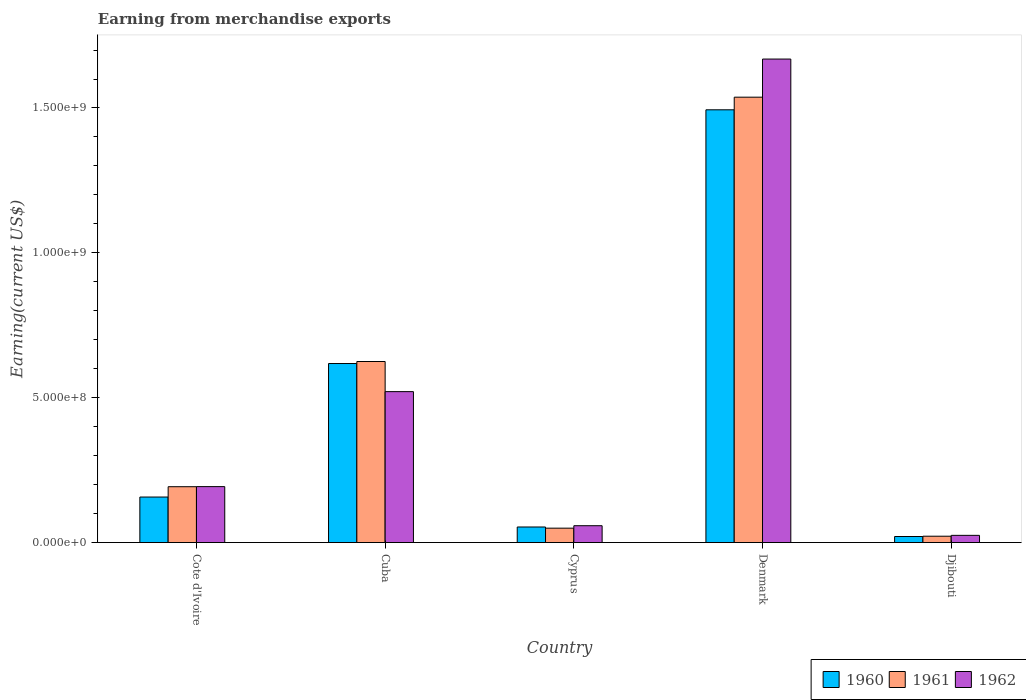How many groups of bars are there?
Provide a short and direct response. 5. Are the number of bars per tick equal to the number of legend labels?
Your answer should be compact. Yes. Are the number of bars on each tick of the X-axis equal?
Make the answer very short. Yes. What is the label of the 4th group of bars from the left?
Provide a short and direct response. Denmark. In how many cases, is the number of bars for a given country not equal to the number of legend labels?
Provide a succinct answer. 0. What is the amount earned from merchandise exports in 1962 in Denmark?
Give a very brief answer. 1.67e+09. Across all countries, what is the maximum amount earned from merchandise exports in 1960?
Provide a succinct answer. 1.49e+09. Across all countries, what is the minimum amount earned from merchandise exports in 1961?
Provide a short and direct response. 2.20e+07. In which country was the amount earned from merchandise exports in 1962 maximum?
Provide a succinct answer. Denmark. In which country was the amount earned from merchandise exports in 1961 minimum?
Offer a terse response. Djibouti. What is the total amount earned from merchandise exports in 1962 in the graph?
Provide a short and direct response. 2.47e+09. What is the difference between the amount earned from merchandise exports in 1961 in Cuba and that in Cyprus?
Ensure brevity in your answer.  5.75e+08. What is the difference between the amount earned from merchandise exports in 1962 in Denmark and the amount earned from merchandise exports in 1960 in Cyprus?
Make the answer very short. 1.62e+09. What is the average amount earned from merchandise exports in 1960 per country?
Ensure brevity in your answer.  4.69e+08. What is the difference between the amount earned from merchandise exports of/in 1960 and amount earned from merchandise exports of/in 1962 in Denmark?
Make the answer very short. -1.75e+08. What is the ratio of the amount earned from merchandise exports in 1960 in Cote d'Ivoire to that in Cyprus?
Offer a very short reply. 2.92. Is the amount earned from merchandise exports in 1961 in Cote d'Ivoire less than that in Djibouti?
Your answer should be very brief. No. Is the difference between the amount earned from merchandise exports in 1960 in Cote d'Ivoire and Cyprus greater than the difference between the amount earned from merchandise exports in 1962 in Cote d'Ivoire and Cyprus?
Offer a very short reply. No. What is the difference between the highest and the second highest amount earned from merchandise exports in 1960?
Your answer should be compact. 8.76e+08. What is the difference between the highest and the lowest amount earned from merchandise exports in 1960?
Make the answer very short. 1.47e+09. In how many countries, is the amount earned from merchandise exports in 1960 greater than the average amount earned from merchandise exports in 1960 taken over all countries?
Your answer should be compact. 2. Is the sum of the amount earned from merchandise exports in 1962 in Cote d'Ivoire and Cyprus greater than the maximum amount earned from merchandise exports in 1960 across all countries?
Your answer should be compact. No. What does the 3rd bar from the left in Denmark represents?
Offer a very short reply. 1962. Is it the case that in every country, the sum of the amount earned from merchandise exports in 1961 and amount earned from merchandise exports in 1960 is greater than the amount earned from merchandise exports in 1962?
Provide a succinct answer. Yes. How many bars are there?
Offer a very short reply. 15. Are the values on the major ticks of Y-axis written in scientific E-notation?
Ensure brevity in your answer.  Yes. How many legend labels are there?
Keep it short and to the point. 3. How are the legend labels stacked?
Keep it short and to the point. Horizontal. What is the title of the graph?
Provide a succinct answer. Earning from merchandise exports. What is the label or title of the X-axis?
Offer a terse response. Country. What is the label or title of the Y-axis?
Provide a short and direct response. Earning(current US$). What is the Earning(current US$) of 1960 in Cote d'Ivoire?
Provide a short and direct response. 1.57e+08. What is the Earning(current US$) in 1961 in Cote d'Ivoire?
Provide a short and direct response. 1.93e+08. What is the Earning(current US$) of 1962 in Cote d'Ivoire?
Provide a succinct answer. 1.93e+08. What is the Earning(current US$) of 1960 in Cuba?
Give a very brief answer. 6.18e+08. What is the Earning(current US$) of 1961 in Cuba?
Your answer should be very brief. 6.25e+08. What is the Earning(current US$) in 1962 in Cuba?
Keep it short and to the point. 5.21e+08. What is the Earning(current US$) in 1960 in Cyprus?
Make the answer very short. 5.38e+07. What is the Earning(current US$) of 1961 in Cyprus?
Give a very brief answer. 4.98e+07. What is the Earning(current US$) of 1962 in Cyprus?
Your response must be concise. 5.82e+07. What is the Earning(current US$) in 1960 in Denmark?
Ensure brevity in your answer.  1.49e+09. What is the Earning(current US$) of 1961 in Denmark?
Offer a very short reply. 1.54e+09. What is the Earning(current US$) of 1962 in Denmark?
Your answer should be very brief. 1.67e+09. What is the Earning(current US$) in 1960 in Djibouti?
Make the answer very short. 2.10e+07. What is the Earning(current US$) in 1961 in Djibouti?
Your response must be concise. 2.20e+07. What is the Earning(current US$) of 1962 in Djibouti?
Keep it short and to the point. 2.50e+07. Across all countries, what is the maximum Earning(current US$) in 1960?
Provide a succinct answer. 1.49e+09. Across all countries, what is the maximum Earning(current US$) of 1961?
Ensure brevity in your answer.  1.54e+09. Across all countries, what is the maximum Earning(current US$) of 1962?
Keep it short and to the point. 1.67e+09. Across all countries, what is the minimum Earning(current US$) in 1960?
Give a very brief answer. 2.10e+07. Across all countries, what is the minimum Earning(current US$) of 1961?
Your answer should be compact. 2.20e+07. Across all countries, what is the minimum Earning(current US$) in 1962?
Your response must be concise. 2.50e+07. What is the total Earning(current US$) of 1960 in the graph?
Give a very brief answer. 2.34e+09. What is the total Earning(current US$) of 1961 in the graph?
Keep it short and to the point. 2.43e+09. What is the total Earning(current US$) in 1962 in the graph?
Make the answer very short. 2.47e+09. What is the difference between the Earning(current US$) of 1960 in Cote d'Ivoire and that in Cuba?
Your answer should be compact. -4.61e+08. What is the difference between the Earning(current US$) of 1961 in Cote d'Ivoire and that in Cuba?
Your answer should be compact. -4.32e+08. What is the difference between the Earning(current US$) in 1962 in Cote d'Ivoire and that in Cuba?
Offer a terse response. -3.28e+08. What is the difference between the Earning(current US$) in 1960 in Cote d'Ivoire and that in Cyprus?
Your answer should be compact. 1.03e+08. What is the difference between the Earning(current US$) in 1961 in Cote d'Ivoire and that in Cyprus?
Your answer should be compact. 1.43e+08. What is the difference between the Earning(current US$) in 1962 in Cote d'Ivoire and that in Cyprus?
Keep it short and to the point. 1.35e+08. What is the difference between the Earning(current US$) in 1960 in Cote d'Ivoire and that in Denmark?
Make the answer very short. -1.34e+09. What is the difference between the Earning(current US$) in 1961 in Cote d'Ivoire and that in Denmark?
Ensure brevity in your answer.  -1.34e+09. What is the difference between the Earning(current US$) in 1962 in Cote d'Ivoire and that in Denmark?
Make the answer very short. -1.48e+09. What is the difference between the Earning(current US$) in 1960 in Cote d'Ivoire and that in Djibouti?
Ensure brevity in your answer.  1.36e+08. What is the difference between the Earning(current US$) of 1961 in Cote d'Ivoire and that in Djibouti?
Offer a very short reply. 1.71e+08. What is the difference between the Earning(current US$) in 1962 in Cote d'Ivoire and that in Djibouti?
Provide a short and direct response. 1.68e+08. What is the difference between the Earning(current US$) in 1960 in Cuba and that in Cyprus?
Give a very brief answer. 5.64e+08. What is the difference between the Earning(current US$) in 1961 in Cuba and that in Cyprus?
Provide a succinct answer. 5.75e+08. What is the difference between the Earning(current US$) in 1962 in Cuba and that in Cyprus?
Your response must be concise. 4.63e+08. What is the difference between the Earning(current US$) in 1960 in Cuba and that in Denmark?
Provide a short and direct response. -8.76e+08. What is the difference between the Earning(current US$) of 1961 in Cuba and that in Denmark?
Offer a very short reply. -9.12e+08. What is the difference between the Earning(current US$) in 1962 in Cuba and that in Denmark?
Offer a terse response. -1.15e+09. What is the difference between the Earning(current US$) of 1960 in Cuba and that in Djibouti?
Offer a terse response. 5.97e+08. What is the difference between the Earning(current US$) of 1961 in Cuba and that in Djibouti?
Make the answer very short. 6.03e+08. What is the difference between the Earning(current US$) of 1962 in Cuba and that in Djibouti?
Your answer should be compact. 4.96e+08. What is the difference between the Earning(current US$) in 1960 in Cyprus and that in Denmark?
Make the answer very short. -1.44e+09. What is the difference between the Earning(current US$) in 1961 in Cyprus and that in Denmark?
Make the answer very short. -1.49e+09. What is the difference between the Earning(current US$) of 1962 in Cyprus and that in Denmark?
Keep it short and to the point. -1.61e+09. What is the difference between the Earning(current US$) of 1960 in Cyprus and that in Djibouti?
Your answer should be very brief. 3.28e+07. What is the difference between the Earning(current US$) in 1961 in Cyprus and that in Djibouti?
Offer a very short reply. 2.78e+07. What is the difference between the Earning(current US$) of 1962 in Cyprus and that in Djibouti?
Make the answer very short. 3.32e+07. What is the difference between the Earning(current US$) of 1960 in Denmark and that in Djibouti?
Give a very brief answer. 1.47e+09. What is the difference between the Earning(current US$) in 1961 in Denmark and that in Djibouti?
Offer a very short reply. 1.52e+09. What is the difference between the Earning(current US$) in 1962 in Denmark and that in Djibouti?
Provide a short and direct response. 1.64e+09. What is the difference between the Earning(current US$) of 1960 in Cote d'Ivoire and the Earning(current US$) of 1961 in Cuba?
Your answer should be very brief. -4.68e+08. What is the difference between the Earning(current US$) in 1960 in Cote d'Ivoire and the Earning(current US$) in 1962 in Cuba?
Make the answer very short. -3.64e+08. What is the difference between the Earning(current US$) of 1961 in Cote d'Ivoire and the Earning(current US$) of 1962 in Cuba?
Your answer should be very brief. -3.28e+08. What is the difference between the Earning(current US$) in 1960 in Cote d'Ivoire and the Earning(current US$) in 1961 in Cyprus?
Make the answer very short. 1.07e+08. What is the difference between the Earning(current US$) of 1960 in Cote d'Ivoire and the Earning(current US$) of 1962 in Cyprus?
Your answer should be very brief. 9.90e+07. What is the difference between the Earning(current US$) of 1961 in Cote d'Ivoire and the Earning(current US$) of 1962 in Cyprus?
Your answer should be compact. 1.35e+08. What is the difference between the Earning(current US$) of 1960 in Cote d'Ivoire and the Earning(current US$) of 1961 in Denmark?
Provide a succinct answer. -1.38e+09. What is the difference between the Earning(current US$) in 1960 in Cote d'Ivoire and the Earning(current US$) in 1962 in Denmark?
Keep it short and to the point. -1.51e+09. What is the difference between the Earning(current US$) in 1961 in Cote d'Ivoire and the Earning(current US$) in 1962 in Denmark?
Your answer should be very brief. -1.48e+09. What is the difference between the Earning(current US$) in 1960 in Cote d'Ivoire and the Earning(current US$) in 1961 in Djibouti?
Your answer should be very brief. 1.35e+08. What is the difference between the Earning(current US$) of 1960 in Cote d'Ivoire and the Earning(current US$) of 1962 in Djibouti?
Your response must be concise. 1.32e+08. What is the difference between the Earning(current US$) of 1961 in Cote d'Ivoire and the Earning(current US$) of 1962 in Djibouti?
Your response must be concise. 1.68e+08. What is the difference between the Earning(current US$) in 1960 in Cuba and the Earning(current US$) in 1961 in Cyprus?
Offer a terse response. 5.68e+08. What is the difference between the Earning(current US$) in 1960 in Cuba and the Earning(current US$) in 1962 in Cyprus?
Make the answer very short. 5.60e+08. What is the difference between the Earning(current US$) in 1961 in Cuba and the Earning(current US$) in 1962 in Cyprus?
Your answer should be compact. 5.67e+08. What is the difference between the Earning(current US$) in 1960 in Cuba and the Earning(current US$) in 1961 in Denmark?
Offer a very short reply. -9.19e+08. What is the difference between the Earning(current US$) of 1960 in Cuba and the Earning(current US$) of 1962 in Denmark?
Make the answer very short. -1.05e+09. What is the difference between the Earning(current US$) in 1961 in Cuba and the Earning(current US$) in 1962 in Denmark?
Offer a terse response. -1.04e+09. What is the difference between the Earning(current US$) of 1960 in Cuba and the Earning(current US$) of 1961 in Djibouti?
Offer a very short reply. 5.96e+08. What is the difference between the Earning(current US$) of 1960 in Cuba and the Earning(current US$) of 1962 in Djibouti?
Keep it short and to the point. 5.93e+08. What is the difference between the Earning(current US$) of 1961 in Cuba and the Earning(current US$) of 1962 in Djibouti?
Your answer should be very brief. 6.00e+08. What is the difference between the Earning(current US$) in 1960 in Cyprus and the Earning(current US$) in 1961 in Denmark?
Your response must be concise. -1.48e+09. What is the difference between the Earning(current US$) of 1960 in Cyprus and the Earning(current US$) of 1962 in Denmark?
Ensure brevity in your answer.  -1.62e+09. What is the difference between the Earning(current US$) of 1961 in Cyprus and the Earning(current US$) of 1962 in Denmark?
Offer a very short reply. -1.62e+09. What is the difference between the Earning(current US$) in 1960 in Cyprus and the Earning(current US$) in 1961 in Djibouti?
Provide a succinct answer. 3.18e+07. What is the difference between the Earning(current US$) in 1960 in Cyprus and the Earning(current US$) in 1962 in Djibouti?
Keep it short and to the point. 2.88e+07. What is the difference between the Earning(current US$) of 1961 in Cyprus and the Earning(current US$) of 1962 in Djibouti?
Keep it short and to the point. 2.48e+07. What is the difference between the Earning(current US$) in 1960 in Denmark and the Earning(current US$) in 1961 in Djibouti?
Your answer should be very brief. 1.47e+09. What is the difference between the Earning(current US$) in 1960 in Denmark and the Earning(current US$) in 1962 in Djibouti?
Your response must be concise. 1.47e+09. What is the difference between the Earning(current US$) in 1961 in Denmark and the Earning(current US$) in 1962 in Djibouti?
Give a very brief answer. 1.51e+09. What is the average Earning(current US$) of 1960 per country?
Offer a terse response. 4.69e+08. What is the average Earning(current US$) in 1961 per country?
Your answer should be very brief. 4.85e+08. What is the average Earning(current US$) of 1962 per country?
Provide a short and direct response. 4.93e+08. What is the difference between the Earning(current US$) of 1960 and Earning(current US$) of 1961 in Cote d'Ivoire?
Provide a succinct answer. -3.56e+07. What is the difference between the Earning(current US$) of 1960 and Earning(current US$) of 1962 in Cote d'Ivoire?
Your answer should be very brief. -3.60e+07. What is the difference between the Earning(current US$) of 1961 and Earning(current US$) of 1962 in Cote d'Ivoire?
Your answer should be compact. -3.24e+05. What is the difference between the Earning(current US$) in 1960 and Earning(current US$) in 1961 in Cuba?
Your response must be concise. -7.00e+06. What is the difference between the Earning(current US$) of 1960 and Earning(current US$) of 1962 in Cuba?
Ensure brevity in your answer.  9.70e+07. What is the difference between the Earning(current US$) of 1961 and Earning(current US$) of 1962 in Cuba?
Your answer should be compact. 1.04e+08. What is the difference between the Earning(current US$) in 1960 and Earning(current US$) in 1961 in Cyprus?
Your response must be concise. 4.07e+06. What is the difference between the Earning(current US$) of 1960 and Earning(current US$) of 1962 in Cyprus?
Offer a very short reply. -4.38e+06. What is the difference between the Earning(current US$) in 1961 and Earning(current US$) in 1962 in Cyprus?
Provide a short and direct response. -8.45e+06. What is the difference between the Earning(current US$) of 1960 and Earning(current US$) of 1961 in Denmark?
Provide a succinct answer. -4.36e+07. What is the difference between the Earning(current US$) of 1960 and Earning(current US$) of 1962 in Denmark?
Provide a short and direct response. -1.75e+08. What is the difference between the Earning(current US$) in 1961 and Earning(current US$) in 1962 in Denmark?
Provide a succinct answer. -1.32e+08. What is the difference between the Earning(current US$) of 1960 and Earning(current US$) of 1962 in Djibouti?
Give a very brief answer. -4.00e+06. What is the ratio of the Earning(current US$) of 1960 in Cote d'Ivoire to that in Cuba?
Provide a succinct answer. 0.25. What is the ratio of the Earning(current US$) of 1961 in Cote d'Ivoire to that in Cuba?
Your answer should be compact. 0.31. What is the ratio of the Earning(current US$) of 1962 in Cote d'Ivoire to that in Cuba?
Keep it short and to the point. 0.37. What is the ratio of the Earning(current US$) of 1960 in Cote d'Ivoire to that in Cyprus?
Provide a short and direct response. 2.92. What is the ratio of the Earning(current US$) of 1961 in Cote d'Ivoire to that in Cyprus?
Provide a short and direct response. 3.87. What is the ratio of the Earning(current US$) of 1962 in Cote d'Ivoire to that in Cyprus?
Ensure brevity in your answer.  3.32. What is the ratio of the Earning(current US$) of 1960 in Cote d'Ivoire to that in Denmark?
Your response must be concise. 0.11. What is the ratio of the Earning(current US$) in 1961 in Cote d'Ivoire to that in Denmark?
Provide a short and direct response. 0.13. What is the ratio of the Earning(current US$) in 1962 in Cote d'Ivoire to that in Denmark?
Your response must be concise. 0.12. What is the ratio of the Earning(current US$) of 1960 in Cote d'Ivoire to that in Djibouti?
Offer a terse response. 7.49. What is the ratio of the Earning(current US$) in 1961 in Cote d'Ivoire to that in Djibouti?
Provide a succinct answer. 8.77. What is the ratio of the Earning(current US$) of 1962 in Cote d'Ivoire to that in Djibouti?
Provide a succinct answer. 7.73. What is the ratio of the Earning(current US$) in 1960 in Cuba to that in Cyprus?
Provide a short and direct response. 11.48. What is the ratio of the Earning(current US$) of 1961 in Cuba to that in Cyprus?
Offer a very short reply. 12.55. What is the ratio of the Earning(current US$) in 1962 in Cuba to that in Cyprus?
Provide a short and direct response. 8.95. What is the ratio of the Earning(current US$) in 1960 in Cuba to that in Denmark?
Ensure brevity in your answer.  0.41. What is the ratio of the Earning(current US$) of 1961 in Cuba to that in Denmark?
Give a very brief answer. 0.41. What is the ratio of the Earning(current US$) in 1962 in Cuba to that in Denmark?
Give a very brief answer. 0.31. What is the ratio of the Earning(current US$) in 1960 in Cuba to that in Djibouti?
Give a very brief answer. 29.43. What is the ratio of the Earning(current US$) of 1961 in Cuba to that in Djibouti?
Offer a very short reply. 28.41. What is the ratio of the Earning(current US$) of 1962 in Cuba to that in Djibouti?
Your answer should be very brief. 20.84. What is the ratio of the Earning(current US$) in 1960 in Cyprus to that in Denmark?
Your answer should be very brief. 0.04. What is the ratio of the Earning(current US$) of 1961 in Cyprus to that in Denmark?
Give a very brief answer. 0.03. What is the ratio of the Earning(current US$) in 1962 in Cyprus to that in Denmark?
Provide a succinct answer. 0.03. What is the ratio of the Earning(current US$) in 1960 in Cyprus to that in Djibouti?
Give a very brief answer. 2.56. What is the ratio of the Earning(current US$) of 1961 in Cyprus to that in Djibouti?
Offer a terse response. 2.26. What is the ratio of the Earning(current US$) in 1962 in Cyprus to that in Djibouti?
Make the answer very short. 2.33. What is the ratio of the Earning(current US$) of 1960 in Denmark to that in Djibouti?
Offer a terse response. 71.13. What is the ratio of the Earning(current US$) of 1961 in Denmark to that in Djibouti?
Offer a terse response. 69.88. What is the ratio of the Earning(current US$) of 1962 in Denmark to that in Djibouti?
Make the answer very short. 66.75. What is the difference between the highest and the second highest Earning(current US$) of 1960?
Your answer should be compact. 8.76e+08. What is the difference between the highest and the second highest Earning(current US$) of 1961?
Keep it short and to the point. 9.12e+08. What is the difference between the highest and the second highest Earning(current US$) in 1962?
Give a very brief answer. 1.15e+09. What is the difference between the highest and the lowest Earning(current US$) of 1960?
Ensure brevity in your answer.  1.47e+09. What is the difference between the highest and the lowest Earning(current US$) of 1961?
Ensure brevity in your answer.  1.52e+09. What is the difference between the highest and the lowest Earning(current US$) of 1962?
Your response must be concise. 1.64e+09. 